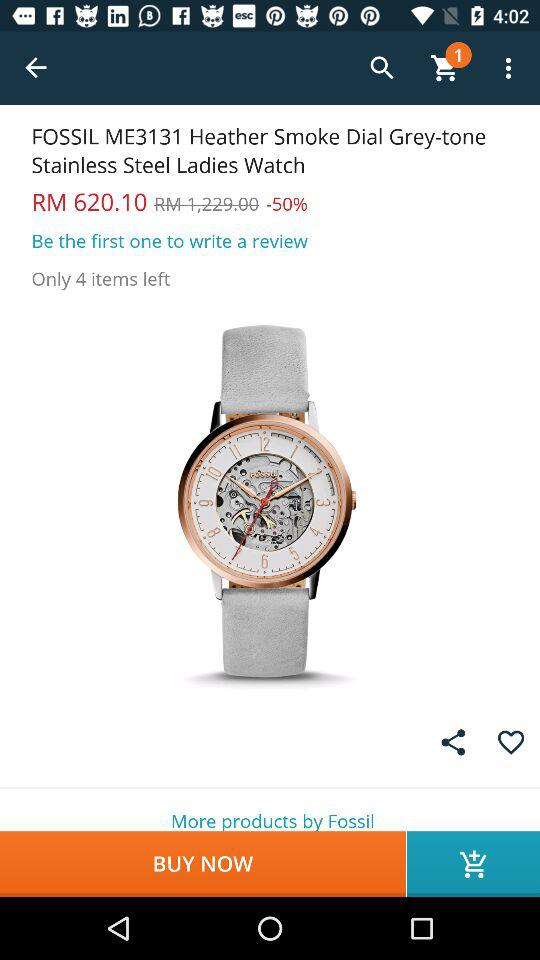How much is the watch discounted by?
Answer the question using a single word or phrase. 50% 